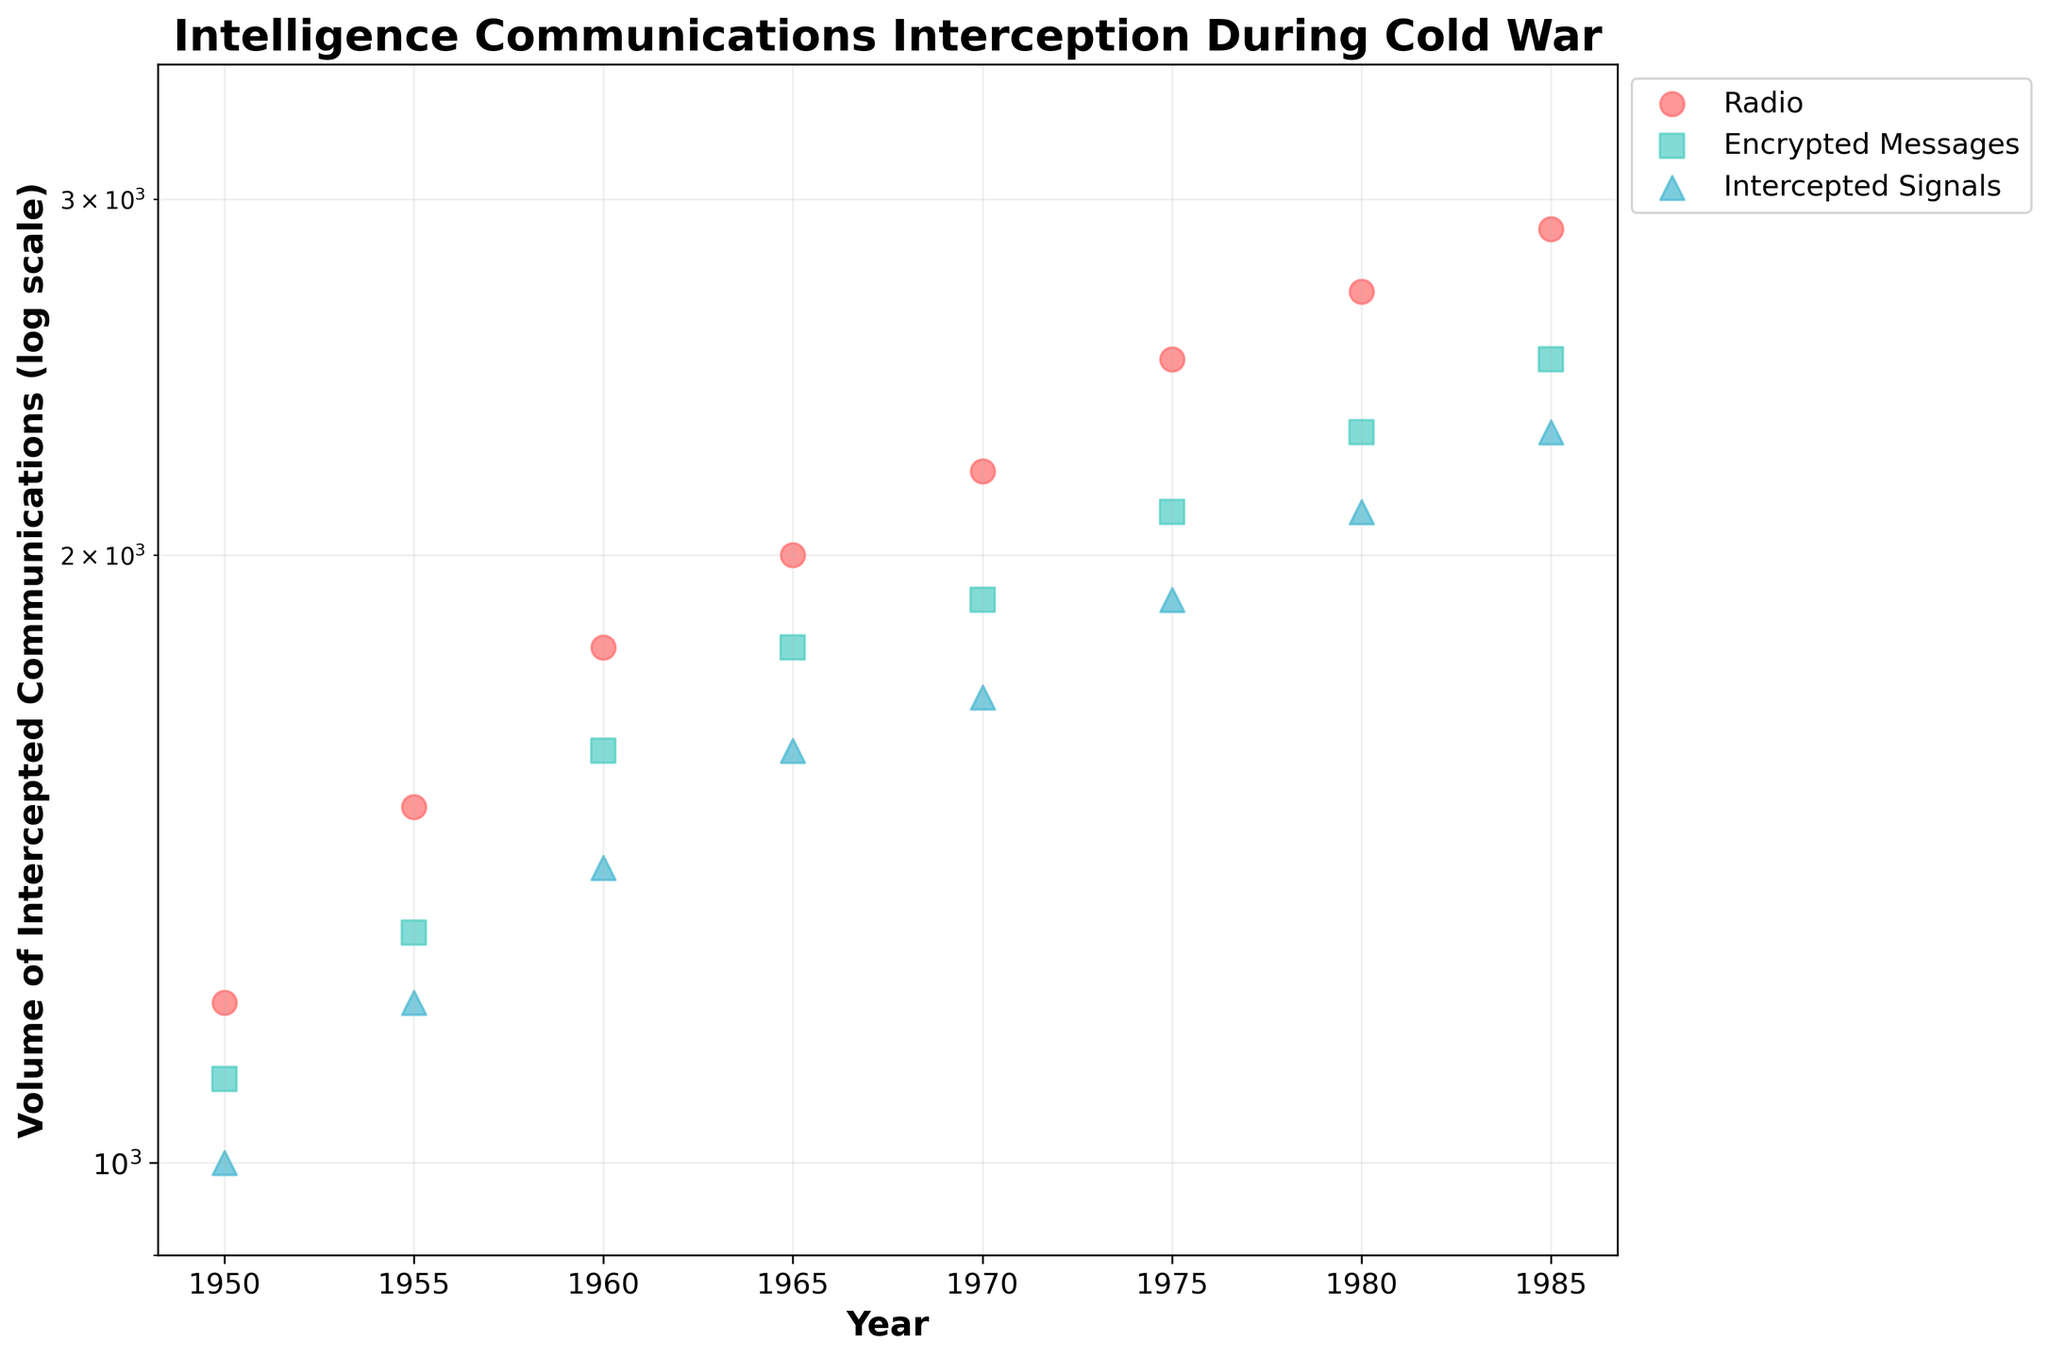What is the title of the figure? The title is typically located at the top of the figure and indicates the main subject of the plot.
Answer: Intelligence Communications Interception During Cold War Which method of interception has the highest volume of intercepted communications in 1975? By examining the values on the y-axis for the year 1975 and comparing the different methods represented by distinct markers and colors, identify the highest volume.
Answer: Radio What is the y-axis scale used in the figure? The y-axis scale determines how data is represented and can show patterns more clearly. Here, the y-axis is mentioned as log scale both in the question and title, ensuring large value ranges are visualized effectively.
Answer: Logarithmic Which method of interception shows a continuous increase in intercepted communication volume from 1950 to 1985? Look for a method where every data point from 1950 to 1985 shows an increase in volume as indicated by their positions on the plot. All three methods (Radio, Encrypted Messages, and Intercepted Signals) should be considered.
Answer: Radio By what percentage did the volume of intercepted communications by the 'Encrypted Messages' method increase from 1955 to 1980? First, find the volumes for 'Encrypted Messages' in 1955 (1300) and 1980 (2300), compute the absolute increase (2300-1300=1000), and then determine the percentage increase relative to the original volume (1000/1300 * 100 ≈ 76.92%).
Answer: Approximately 76.92% In what year did 'Intercepted Signals' first reach a volume of intercepted communications of 2000? Check the y-axis values for 'Intercepted Signals' and find the year that corresponds to 2000, examining each data point for 'Intercepted Signals' sequentially.
Answer: 1980 Which method of interception had the smallest initial volume in 1950, and what was its value? Compare the y-axis values for each method in the year 1950. The method with the smallest value on the y-axis is identified.
Answer: Intercepted Signals, 1000 Between which consecutive periods did 'Radio' interception experience the greatest increase in intercepted communications volume? Calculate the difference in volumes for consecutive periods, then compare each difference. For 'Radio': 1950-1955 (300), 1955-1960 (300), 1960-1965 (200), 1965-1970 (200), 1970-1975 (300), 1975-1980 (200), 1980-1985 (200). The highest increase is between 1950 and 1960.
Answer: 1955 to 1960 How does the volume of intercepted communications by 'Encrypted Messages' in 1975 compare with 'Intercepted Signals' in 1975? Look at the y-axis values for both 'Encrypted Messages' and 'Intercepted Signals' for the year 1975. Encrypted Messages is at 2100 and Intercepted Signals is at 1900. Compare these two values.
Answer: Encrypted Messages was higher What was the average volume of intercepted communications by 'Radio' from 1950 to 1985? Sum the volumes for 'Radio': (1200 + 1500 + 1800 + 2000 + 2200 + 2500 + 2700 + 2900 = 16800). Then, divide by the number of data points (8).
Answer: 2100 